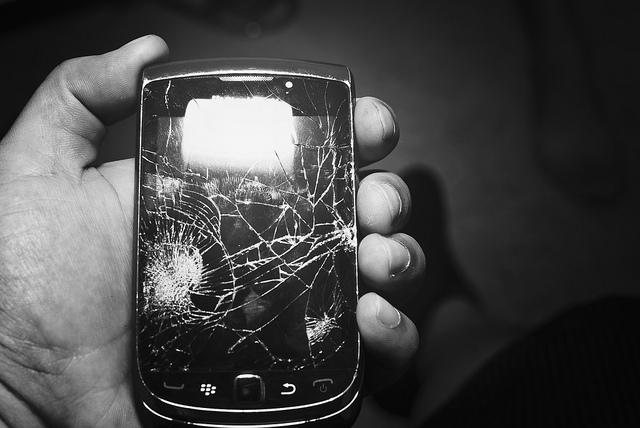<image>What make is this phone? I am not sure what make this phone is. It could be a Blackberry, an HTC, or a Nokia. What make is this phone? I am not sure what make this phone is. It can be seen as 'windows', 'htc', 'blackberry', 'lg', or 'nokia'. 